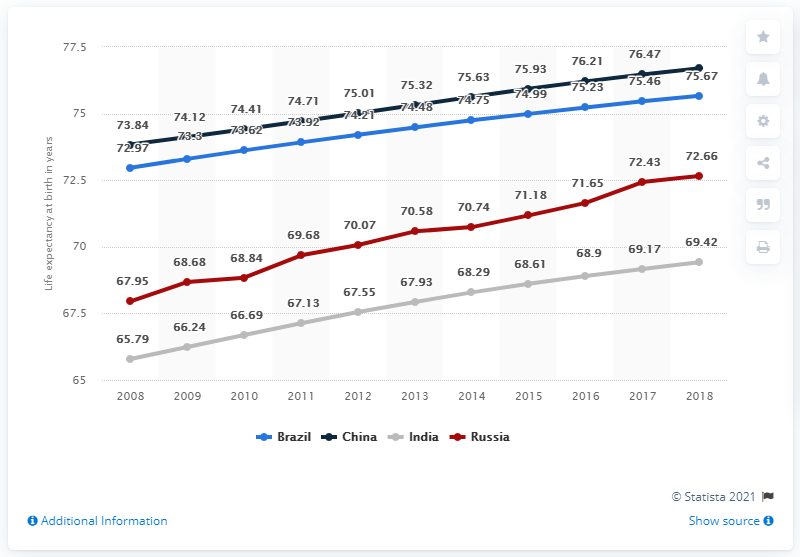Outline some significant characteristics in this image. In 2013, the recorded value in the red line chart was 70.58. The average of all the data in 2017 was 73.38. 